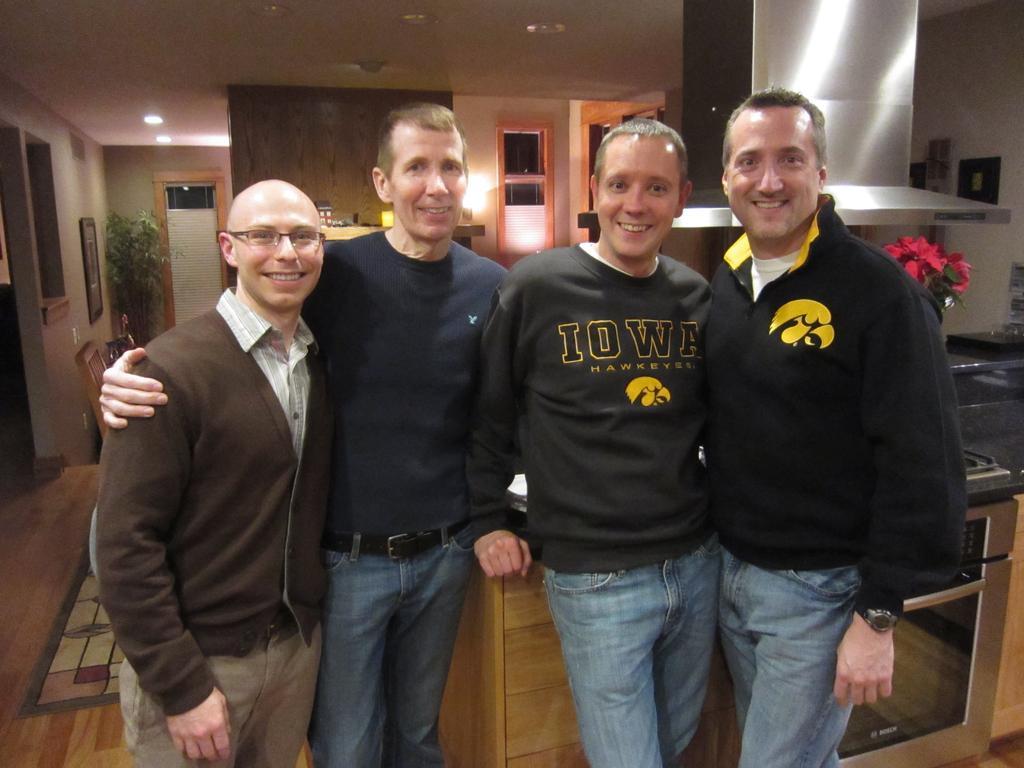In one or two sentences, can you explain what this image depicts? In this picture there are men standing and smiling, behind these men we can see cupboard, flowers, oven and chimney. In the background of the image we can see wall, frames, windows, plant and objects on the shelf. At the top of the image we can see lights. 